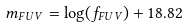<formula> <loc_0><loc_0><loc_500><loc_500>m _ { F U V } = \log ( f _ { F U V } ) + 1 8 . 8 2</formula> 